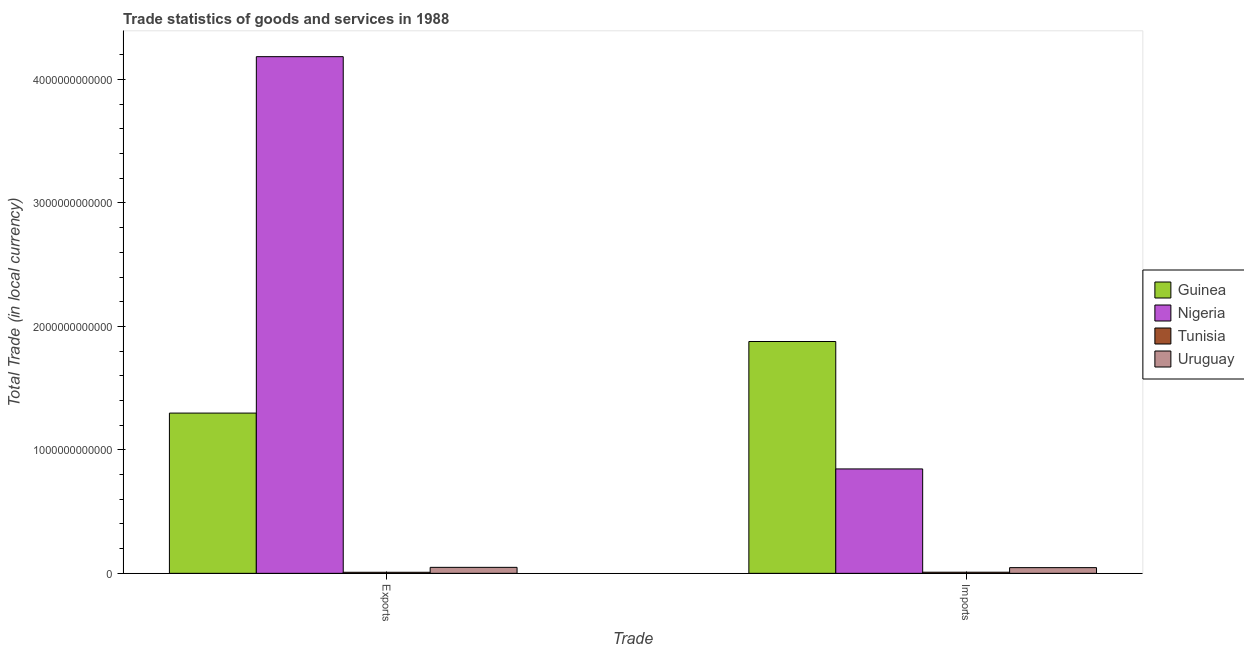How many different coloured bars are there?
Keep it short and to the point. 4. How many groups of bars are there?
Ensure brevity in your answer.  2. How many bars are there on the 2nd tick from the right?
Keep it short and to the point. 4. What is the label of the 2nd group of bars from the left?
Your response must be concise. Imports. What is the export of goods and services in Uruguay?
Offer a very short reply. 4.84e+1. Across all countries, what is the maximum imports of goods and services?
Make the answer very short. 1.88e+12. Across all countries, what is the minimum imports of goods and services?
Offer a terse response. 9.03e+09. In which country was the imports of goods and services maximum?
Ensure brevity in your answer.  Guinea. In which country was the imports of goods and services minimum?
Provide a short and direct response. Tunisia. What is the total export of goods and services in the graph?
Your response must be concise. 5.54e+12. What is the difference between the imports of goods and services in Nigeria and that in Uruguay?
Give a very brief answer. 7.99e+11. What is the difference between the export of goods and services in Guinea and the imports of goods and services in Tunisia?
Make the answer very short. 1.29e+12. What is the average imports of goods and services per country?
Provide a succinct answer. 6.95e+11. What is the difference between the imports of goods and services and export of goods and services in Nigeria?
Offer a very short reply. -3.34e+12. What is the ratio of the export of goods and services in Guinea to that in Tunisia?
Ensure brevity in your answer.  151.53. In how many countries, is the imports of goods and services greater than the average imports of goods and services taken over all countries?
Ensure brevity in your answer.  2. What does the 3rd bar from the left in Imports represents?
Keep it short and to the point. Tunisia. What does the 2nd bar from the right in Exports represents?
Offer a very short reply. Tunisia. Are all the bars in the graph horizontal?
Offer a terse response. No. How many countries are there in the graph?
Your answer should be compact. 4. What is the difference between two consecutive major ticks on the Y-axis?
Provide a short and direct response. 1.00e+12. Does the graph contain any zero values?
Your response must be concise. No. Does the graph contain grids?
Provide a short and direct response. No. How many legend labels are there?
Your answer should be compact. 4. What is the title of the graph?
Provide a short and direct response. Trade statistics of goods and services in 1988. What is the label or title of the X-axis?
Your answer should be very brief. Trade. What is the label or title of the Y-axis?
Provide a short and direct response. Total Trade (in local currency). What is the Total Trade (in local currency) in Guinea in Exports?
Keep it short and to the point. 1.30e+12. What is the Total Trade (in local currency) of Nigeria in Exports?
Give a very brief answer. 4.18e+12. What is the Total Trade (in local currency) of Tunisia in Exports?
Provide a succinct answer. 8.57e+09. What is the Total Trade (in local currency) of Uruguay in Exports?
Give a very brief answer. 4.84e+1. What is the Total Trade (in local currency) in Guinea in Imports?
Make the answer very short. 1.88e+12. What is the Total Trade (in local currency) in Nigeria in Imports?
Give a very brief answer. 8.46e+11. What is the Total Trade (in local currency) of Tunisia in Imports?
Provide a succinct answer. 9.03e+09. What is the Total Trade (in local currency) of Uruguay in Imports?
Your answer should be compact. 4.62e+1. Across all Trade, what is the maximum Total Trade (in local currency) in Guinea?
Keep it short and to the point. 1.88e+12. Across all Trade, what is the maximum Total Trade (in local currency) in Nigeria?
Your answer should be very brief. 4.18e+12. Across all Trade, what is the maximum Total Trade (in local currency) in Tunisia?
Provide a succinct answer. 9.03e+09. Across all Trade, what is the maximum Total Trade (in local currency) in Uruguay?
Ensure brevity in your answer.  4.84e+1. Across all Trade, what is the minimum Total Trade (in local currency) in Guinea?
Ensure brevity in your answer.  1.30e+12. Across all Trade, what is the minimum Total Trade (in local currency) in Nigeria?
Make the answer very short. 8.46e+11. Across all Trade, what is the minimum Total Trade (in local currency) in Tunisia?
Ensure brevity in your answer.  8.57e+09. Across all Trade, what is the minimum Total Trade (in local currency) of Uruguay?
Keep it short and to the point. 4.62e+1. What is the total Total Trade (in local currency) in Guinea in the graph?
Keep it short and to the point. 3.18e+12. What is the total Total Trade (in local currency) in Nigeria in the graph?
Make the answer very short. 5.03e+12. What is the total Total Trade (in local currency) of Tunisia in the graph?
Offer a terse response. 1.76e+1. What is the total Total Trade (in local currency) of Uruguay in the graph?
Your response must be concise. 9.46e+1. What is the difference between the Total Trade (in local currency) of Guinea in Exports and that in Imports?
Your response must be concise. -5.80e+11. What is the difference between the Total Trade (in local currency) of Nigeria in Exports and that in Imports?
Give a very brief answer. 3.34e+12. What is the difference between the Total Trade (in local currency) of Tunisia in Exports and that in Imports?
Your answer should be compact. -4.67e+08. What is the difference between the Total Trade (in local currency) of Uruguay in Exports and that in Imports?
Your response must be concise. 2.21e+09. What is the difference between the Total Trade (in local currency) in Guinea in Exports and the Total Trade (in local currency) in Nigeria in Imports?
Offer a terse response. 4.52e+11. What is the difference between the Total Trade (in local currency) in Guinea in Exports and the Total Trade (in local currency) in Tunisia in Imports?
Offer a terse response. 1.29e+12. What is the difference between the Total Trade (in local currency) of Guinea in Exports and the Total Trade (in local currency) of Uruguay in Imports?
Keep it short and to the point. 1.25e+12. What is the difference between the Total Trade (in local currency) in Nigeria in Exports and the Total Trade (in local currency) in Tunisia in Imports?
Keep it short and to the point. 4.18e+12. What is the difference between the Total Trade (in local currency) of Nigeria in Exports and the Total Trade (in local currency) of Uruguay in Imports?
Offer a very short reply. 4.14e+12. What is the difference between the Total Trade (in local currency) of Tunisia in Exports and the Total Trade (in local currency) of Uruguay in Imports?
Provide a succinct answer. -3.76e+1. What is the average Total Trade (in local currency) in Guinea per Trade?
Make the answer very short. 1.59e+12. What is the average Total Trade (in local currency) of Nigeria per Trade?
Give a very brief answer. 2.52e+12. What is the average Total Trade (in local currency) of Tunisia per Trade?
Make the answer very short. 8.80e+09. What is the average Total Trade (in local currency) in Uruguay per Trade?
Provide a succinct answer. 4.73e+1. What is the difference between the Total Trade (in local currency) of Guinea and Total Trade (in local currency) of Nigeria in Exports?
Keep it short and to the point. -2.89e+12. What is the difference between the Total Trade (in local currency) in Guinea and Total Trade (in local currency) in Tunisia in Exports?
Ensure brevity in your answer.  1.29e+12. What is the difference between the Total Trade (in local currency) of Guinea and Total Trade (in local currency) of Uruguay in Exports?
Offer a very short reply. 1.25e+12. What is the difference between the Total Trade (in local currency) of Nigeria and Total Trade (in local currency) of Tunisia in Exports?
Offer a very short reply. 4.18e+12. What is the difference between the Total Trade (in local currency) of Nigeria and Total Trade (in local currency) of Uruguay in Exports?
Your answer should be very brief. 4.14e+12. What is the difference between the Total Trade (in local currency) of Tunisia and Total Trade (in local currency) of Uruguay in Exports?
Ensure brevity in your answer.  -3.98e+1. What is the difference between the Total Trade (in local currency) in Guinea and Total Trade (in local currency) in Nigeria in Imports?
Ensure brevity in your answer.  1.03e+12. What is the difference between the Total Trade (in local currency) of Guinea and Total Trade (in local currency) of Tunisia in Imports?
Give a very brief answer. 1.87e+12. What is the difference between the Total Trade (in local currency) of Guinea and Total Trade (in local currency) of Uruguay in Imports?
Provide a succinct answer. 1.83e+12. What is the difference between the Total Trade (in local currency) in Nigeria and Total Trade (in local currency) in Tunisia in Imports?
Your response must be concise. 8.37e+11. What is the difference between the Total Trade (in local currency) in Nigeria and Total Trade (in local currency) in Uruguay in Imports?
Keep it short and to the point. 7.99e+11. What is the difference between the Total Trade (in local currency) of Tunisia and Total Trade (in local currency) of Uruguay in Imports?
Make the answer very short. -3.72e+1. What is the ratio of the Total Trade (in local currency) in Guinea in Exports to that in Imports?
Offer a very short reply. 0.69. What is the ratio of the Total Trade (in local currency) in Nigeria in Exports to that in Imports?
Your answer should be compact. 4.95. What is the ratio of the Total Trade (in local currency) of Tunisia in Exports to that in Imports?
Offer a very short reply. 0.95. What is the ratio of the Total Trade (in local currency) in Uruguay in Exports to that in Imports?
Offer a terse response. 1.05. What is the difference between the highest and the second highest Total Trade (in local currency) in Guinea?
Ensure brevity in your answer.  5.80e+11. What is the difference between the highest and the second highest Total Trade (in local currency) of Nigeria?
Offer a very short reply. 3.34e+12. What is the difference between the highest and the second highest Total Trade (in local currency) in Tunisia?
Provide a succinct answer. 4.67e+08. What is the difference between the highest and the second highest Total Trade (in local currency) in Uruguay?
Ensure brevity in your answer.  2.21e+09. What is the difference between the highest and the lowest Total Trade (in local currency) of Guinea?
Provide a short and direct response. 5.80e+11. What is the difference between the highest and the lowest Total Trade (in local currency) of Nigeria?
Keep it short and to the point. 3.34e+12. What is the difference between the highest and the lowest Total Trade (in local currency) in Tunisia?
Give a very brief answer. 4.67e+08. What is the difference between the highest and the lowest Total Trade (in local currency) of Uruguay?
Keep it short and to the point. 2.21e+09. 